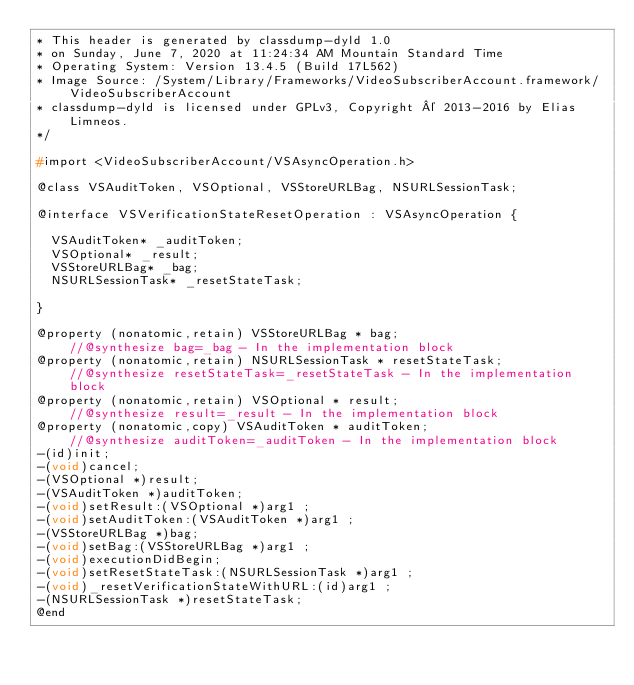<code> <loc_0><loc_0><loc_500><loc_500><_C_>* This header is generated by classdump-dyld 1.0
* on Sunday, June 7, 2020 at 11:24:34 AM Mountain Standard Time
* Operating System: Version 13.4.5 (Build 17L562)
* Image Source: /System/Library/Frameworks/VideoSubscriberAccount.framework/VideoSubscriberAccount
* classdump-dyld is licensed under GPLv3, Copyright © 2013-2016 by Elias Limneos.
*/

#import <VideoSubscriberAccount/VSAsyncOperation.h>

@class VSAuditToken, VSOptional, VSStoreURLBag, NSURLSessionTask;

@interface VSVerificationStateResetOperation : VSAsyncOperation {

	VSAuditToken* _auditToken;
	VSOptional* _result;
	VSStoreURLBag* _bag;
	NSURLSessionTask* _resetStateTask;

}

@property (nonatomic,retain) VSStoreURLBag * bag;                            //@synthesize bag=_bag - In the implementation block
@property (nonatomic,retain) NSURLSessionTask * resetStateTask;              //@synthesize resetStateTask=_resetStateTask - In the implementation block
@property (nonatomic,retain) VSOptional * result;                            //@synthesize result=_result - In the implementation block
@property (nonatomic,copy) VSAuditToken * auditToken;                        //@synthesize auditToken=_auditToken - In the implementation block
-(id)init;
-(void)cancel;
-(VSOptional *)result;
-(VSAuditToken *)auditToken;
-(void)setResult:(VSOptional *)arg1 ;
-(void)setAuditToken:(VSAuditToken *)arg1 ;
-(VSStoreURLBag *)bag;
-(void)setBag:(VSStoreURLBag *)arg1 ;
-(void)executionDidBegin;
-(void)setResetStateTask:(NSURLSessionTask *)arg1 ;
-(void)_resetVerificationStateWithURL:(id)arg1 ;
-(NSURLSessionTask *)resetStateTask;
@end

</code> 